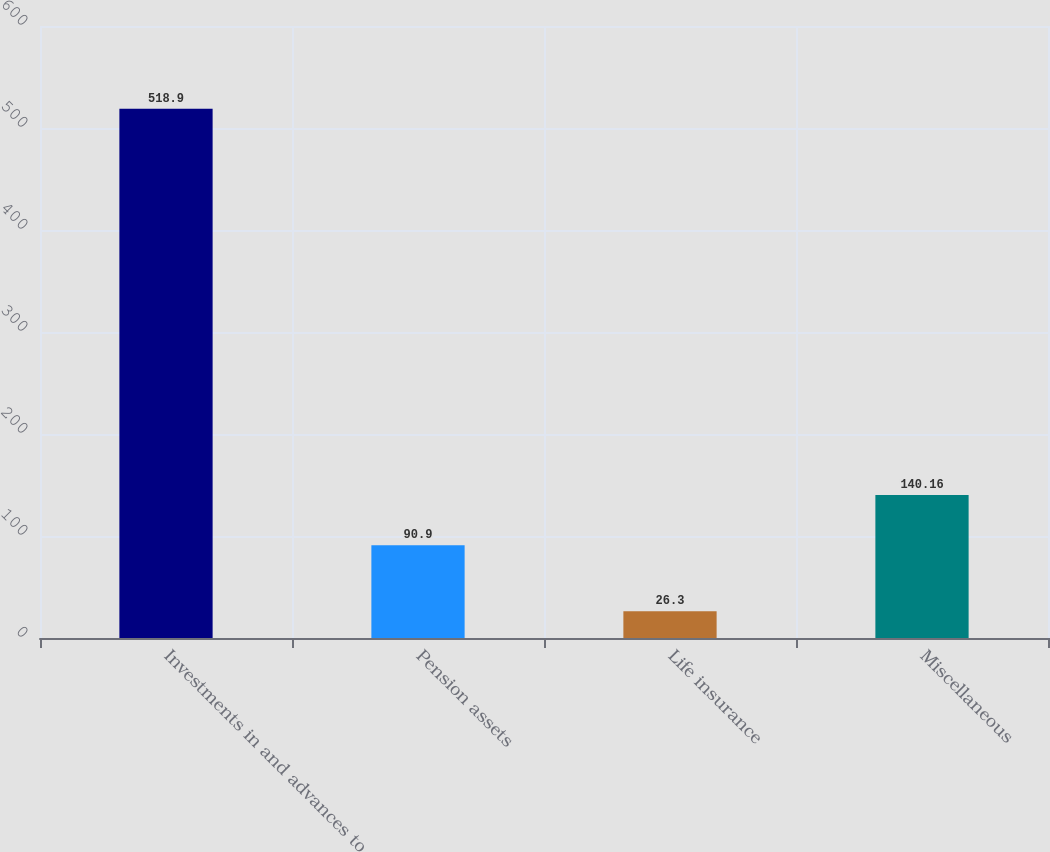Convert chart. <chart><loc_0><loc_0><loc_500><loc_500><bar_chart><fcel>Investments in and advances to<fcel>Pension assets<fcel>Life insurance<fcel>Miscellaneous<nl><fcel>518.9<fcel>90.9<fcel>26.3<fcel>140.16<nl></chart> 